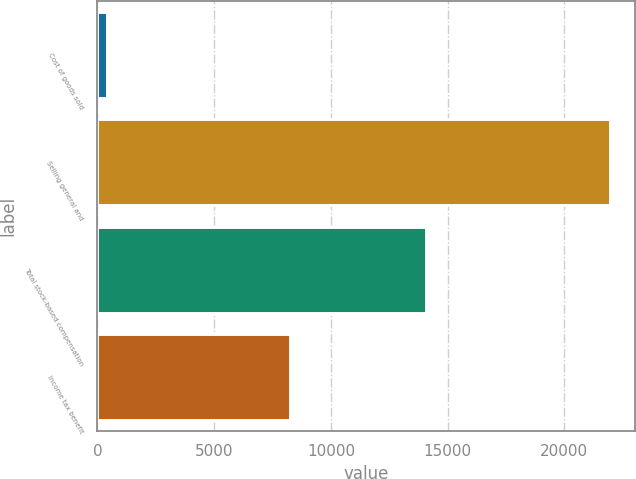<chart> <loc_0><loc_0><loc_500><loc_500><bar_chart><fcel>Cost of goods sold<fcel>Selling general and<fcel>Total stock-based compensation<fcel>Income tax benefit<nl><fcel>407<fcel>21938<fcel>14077<fcel>8268<nl></chart> 